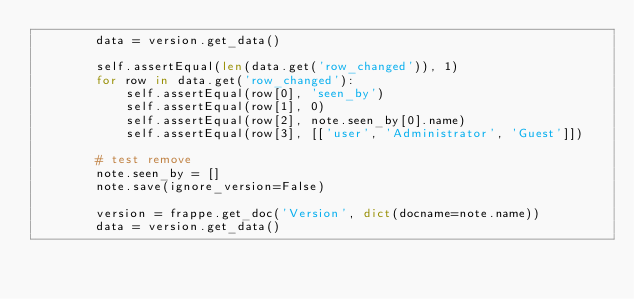Convert code to text. <code><loc_0><loc_0><loc_500><loc_500><_Python_>		data = version.get_data()

		self.assertEqual(len(data.get('row_changed')), 1)
		for row in data.get('row_changed'):
			self.assertEqual(row[0], 'seen_by')
			self.assertEqual(row[1], 0)
			self.assertEqual(row[2], note.seen_by[0].name)
			self.assertEqual(row[3], [['user', 'Administrator', 'Guest']])

		# test remove
		note.seen_by = []
		note.save(ignore_version=False)

		version = frappe.get_doc('Version', dict(docname=note.name))
		data = version.get_data()
</code> 